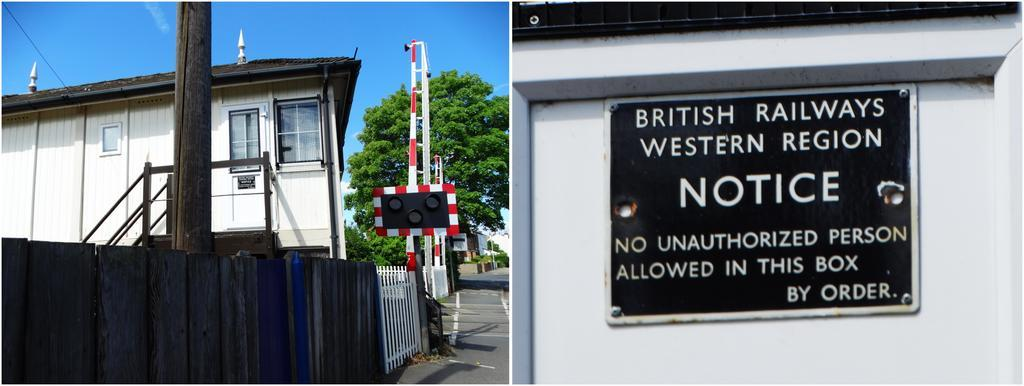What is on the wall in the image? There is a name board on board on the wall in the image. What can be seen in the image besides the name board? There is a fence, trees, a footpath, buildings with windows, and the sky visible in the background of the image. Can you describe the fence in the image? The fence is a linear structure that separates or encloses areas in the image. How many buildings with windows are visible in the image? There are buildings with windows in the image, but the exact number is not specified. How many planes are flying in the sky in the image? There are no planes visible in the sky in the image. What type of peace symbol can be seen on the name board in the image? There is no peace symbol present on the name board in the image. 